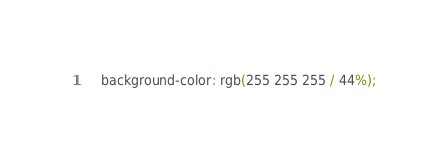Convert code to text. <code><loc_0><loc_0><loc_500><loc_500><_CSS_>    background-color: rgb(255 255 255 / 44%);</code> 